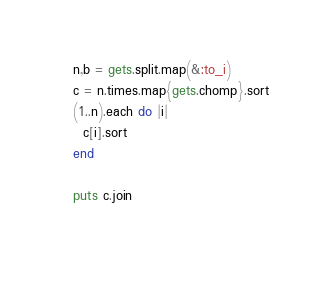Convert code to text. <code><loc_0><loc_0><loc_500><loc_500><_Ruby_>n,b = gets.split.map(&:to_i)
c = n.times.map{gets.chomp}.sort
(1..n).each do |i|
  c[i].sort
end

puts c.join
  
</code> 